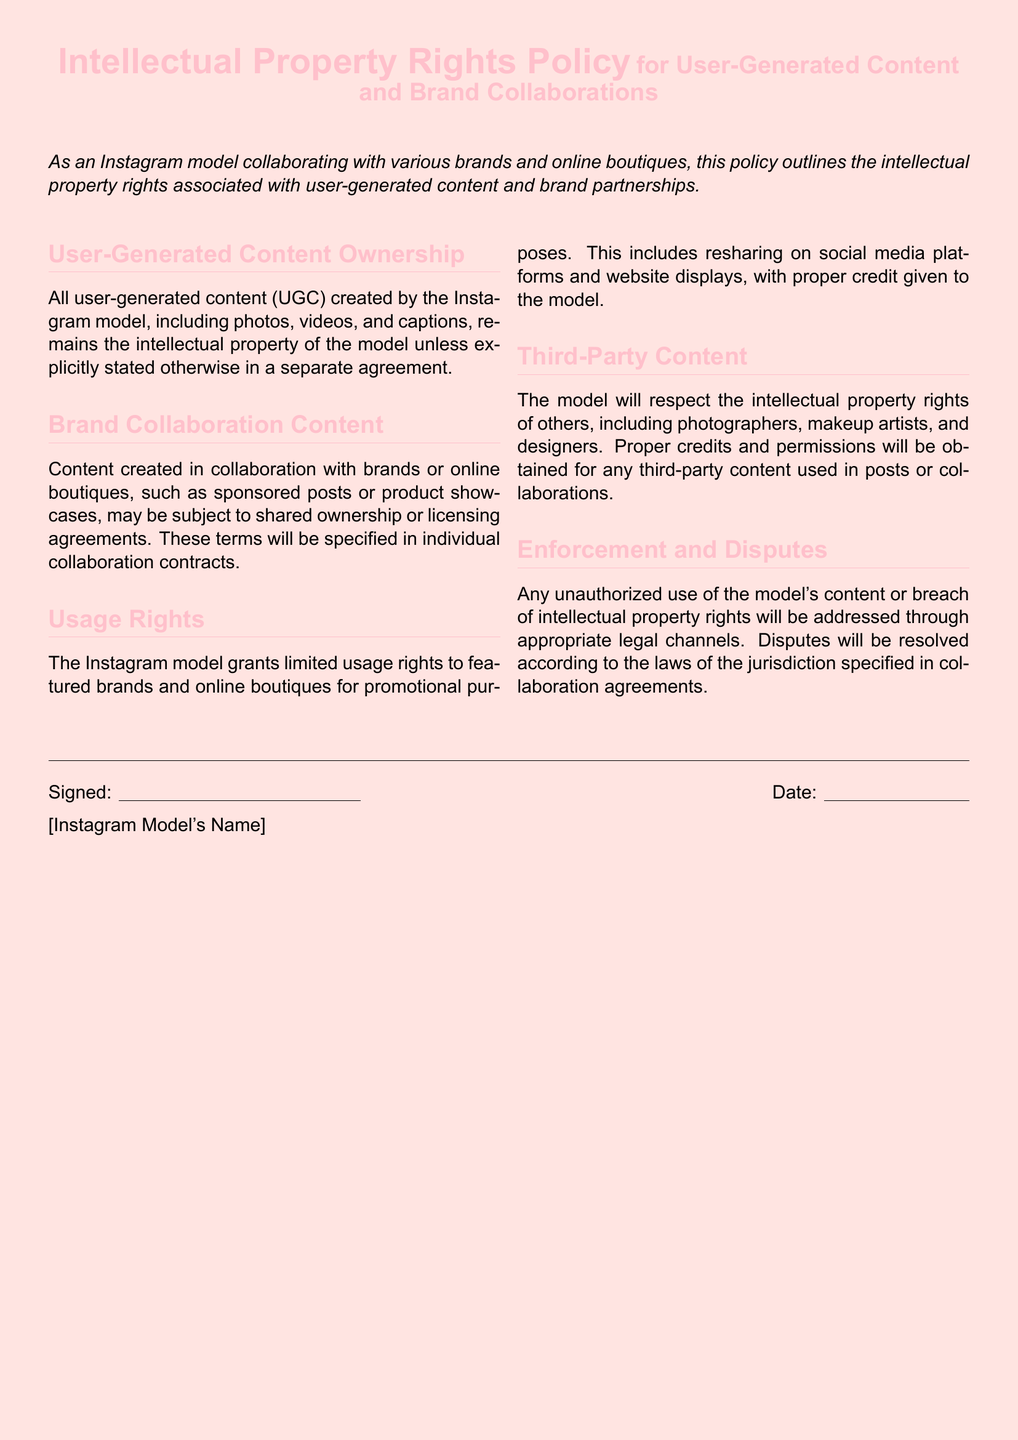What remains the intellectual property of the Instagram model? User-generated content created by the model remains their intellectual property unless stated otherwise.
Answer: intellectual property What may be subject to shared ownership? Content created in collaboration with brands or online boutiques may be subject to shared ownership or licensing agreements.
Answer: shared ownership What rights are granted to brands for promotional use? The Instagram model grants limited usage rights for promotional purposes including resharing on social media platforms and website displays.
Answer: limited usage rights Who must be credited for third-party content used? Proper credits and permissions must be obtained for any third-party content used in posts or collaborations.
Answer: photographers, makeup artists, and designers What will happen in case of unauthorized use of content? Unauthorized use of the model's content will be addressed through appropriate legal channels.
Answer: legal channels How is dispute resolution handled? Disputes will be resolved according to the laws of the jurisdiction specified in collaboration agreements.
Answer: jurisdiction specified What is the document's primary focus? The primary focus of the document is the intellectual property rights associated with user-generated content and brand partnerships.
Answer: intellectual property rights What type of content does the policy cover? The policy covers photos, videos, and captions created by the Instagram model.
Answer: photos, videos, and captions 